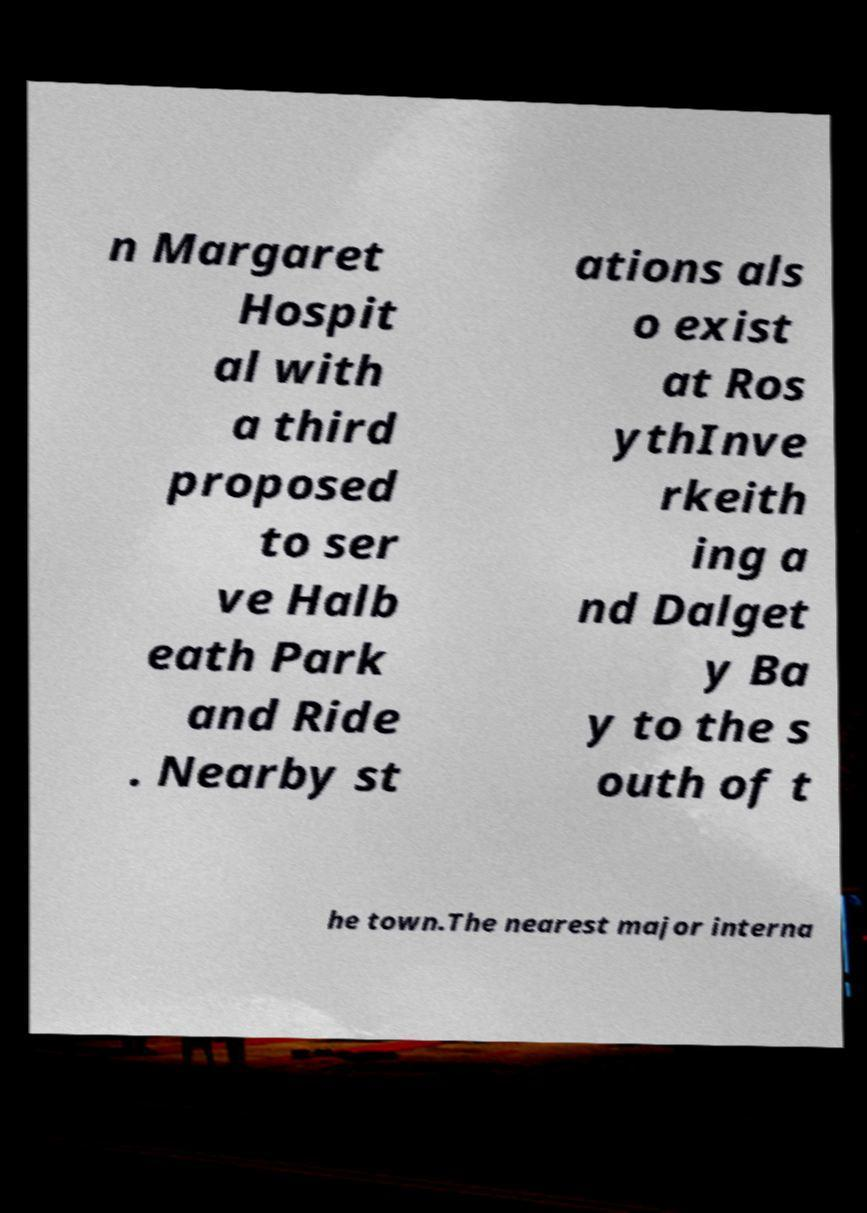For documentation purposes, I need the text within this image transcribed. Could you provide that? n Margaret Hospit al with a third proposed to ser ve Halb eath Park and Ride . Nearby st ations als o exist at Ros ythInve rkeith ing a nd Dalget y Ba y to the s outh of t he town.The nearest major interna 